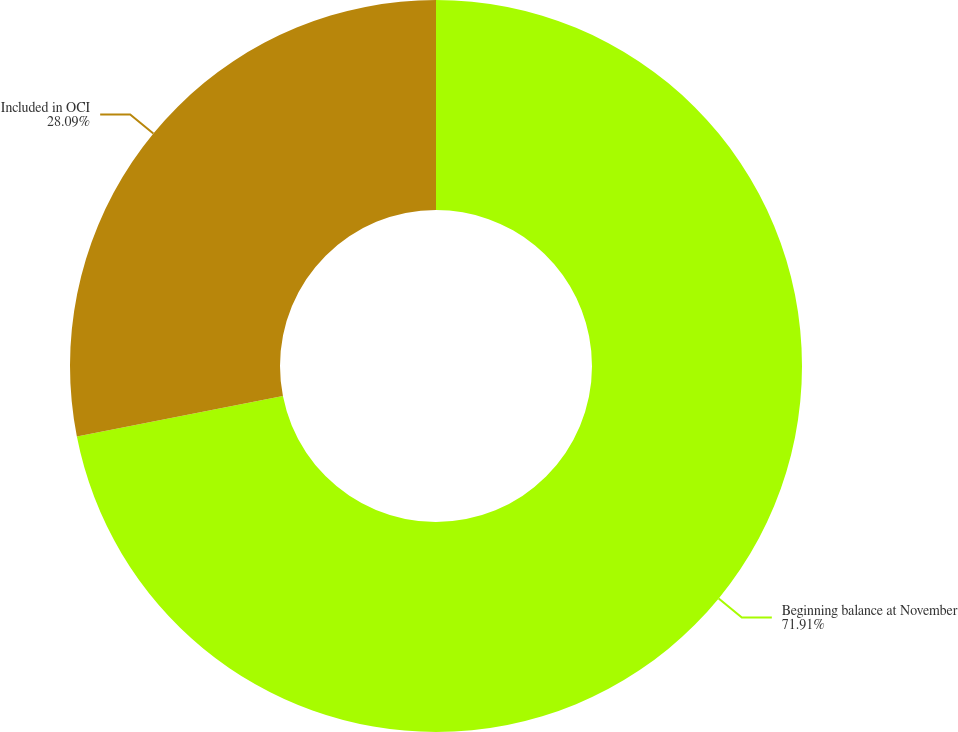Convert chart to OTSL. <chart><loc_0><loc_0><loc_500><loc_500><pie_chart><fcel>Beginning balance at November<fcel>Included in OCI<nl><fcel>71.91%<fcel>28.09%<nl></chart> 